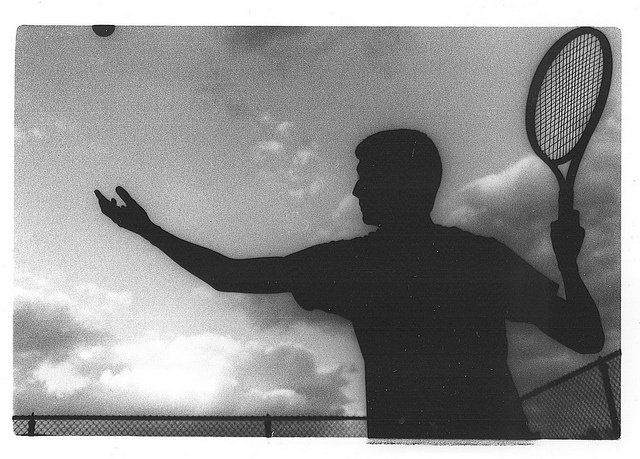Describe the objects in this image and their specific colors. I can see people in white, black, gray, darkgray, and lightgray tones, tennis racket in white, black, gray, darkgray, and lightgray tones, and sports ball in black and white tones in this image. 